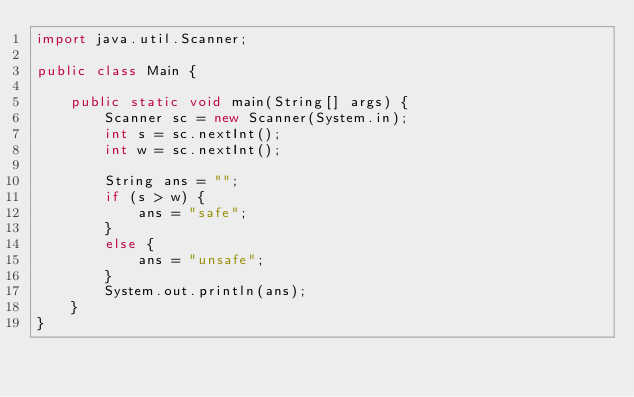<code> <loc_0><loc_0><loc_500><loc_500><_Java_>import java.util.Scanner;

public class Main {

    public static void main(String[] args) {
        Scanner sc = new Scanner(System.in);
        int s = sc.nextInt();
        int w = sc.nextInt();

        String ans = "";
        if (s > w) {
            ans = "safe";
        }
        else {
            ans = "unsafe";
        }
        System.out.println(ans);
    }
}</code> 